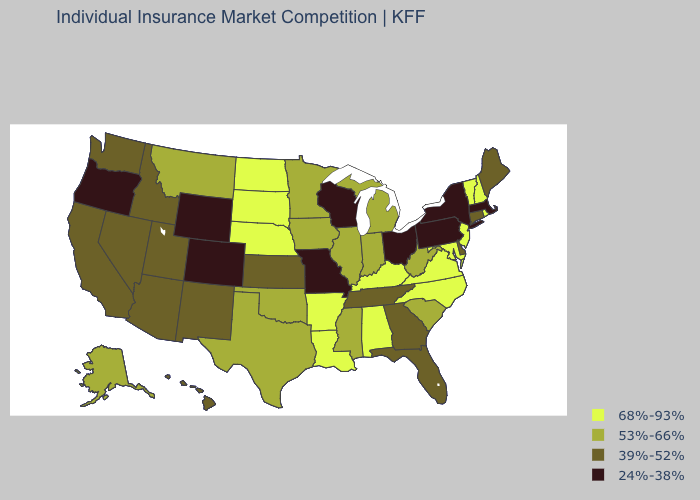Name the states that have a value in the range 53%-66%?
Quick response, please. Alaska, Illinois, Indiana, Iowa, Michigan, Minnesota, Mississippi, Montana, Oklahoma, South Carolina, Texas, West Virginia. Which states have the highest value in the USA?
Keep it brief. Alabama, Arkansas, Kentucky, Louisiana, Maryland, Nebraska, New Hampshire, New Jersey, North Carolina, North Dakota, Rhode Island, South Dakota, Vermont, Virginia. What is the value of Wyoming?
Answer briefly. 24%-38%. Does Alabama have the same value as South Carolina?
Quick response, please. No. Does the map have missing data?
Short answer required. No. Which states have the lowest value in the USA?
Give a very brief answer. Colorado, Massachusetts, Missouri, New York, Ohio, Oregon, Pennsylvania, Wisconsin, Wyoming. Among the states that border Delaware , which have the highest value?
Quick response, please. Maryland, New Jersey. What is the lowest value in the MidWest?
Write a very short answer. 24%-38%. What is the value of Utah?
Concise answer only. 39%-52%. What is the value of Arkansas?
Give a very brief answer. 68%-93%. Which states have the highest value in the USA?
Short answer required. Alabama, Arkansas, Kentucky, Louisiana, Maryland, Nebraska, New Hampshire, New Jersey, North Carolina, North Dakota, Rhode Island, South Dakota, Vermont, Virginia. What is the value of Vermont?
Concise answer only. 68%-93%. What is the value of Montana?
Quick response, please. 53%-66%. What is the lowest value in the Northeast?
Be succinct. 24%-38%. 